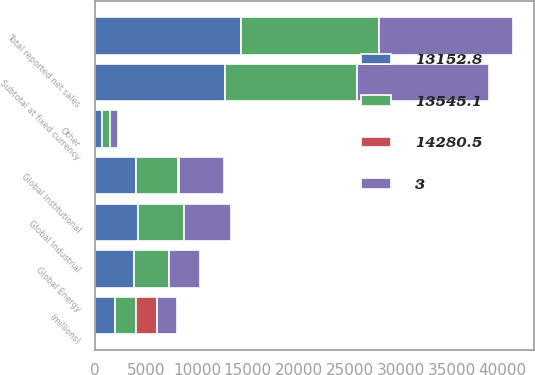Convert chart. <chart><loc_0><loc_0><loc_500><loc_500><stacked_bar_chart><ecel><fcel>(millions)<fcel>Global Industrial<fcel>Global Institutional<fcel>Global Energy<fcel>Other<fcel>Subtotal at fixed currency<fcel>Total reported net sales<nl><fcel>3<fcel>2016<fcel>4617.1<fcel>4495.6<fcel>3035.8<fcel>806.5<fcel>12955<fcel>13152.8<nl><fcel>13545.1<fcel>2015<fcel>4485.5<fcel>4210.9<fcel>3470.8<fcel>747.1<fcel>12914.3<fcel>13545.1<nl><fcel>13152.8<fcel>2014<fcel>4261.9<fcel>3982.8<fcel>3815.8<fcel>705.2<fcel>12765.7<fcel>14280.5<nl><fcel>14280.5<fcel>2016<fcel>3<fcel>7<fcel>13<fcel>8<fcel>0<fcel>3<nl></chart> 